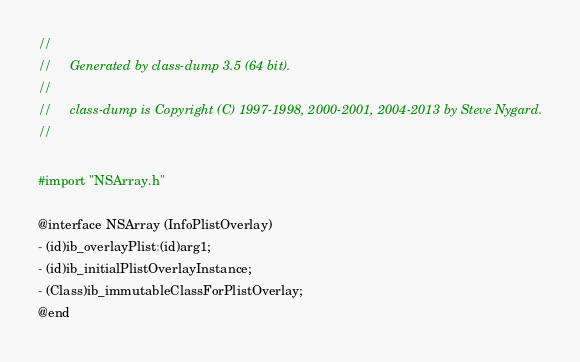<code> <loc_0><loc_0><loc_500><loc_500><_C_>//
//     Generated by class-dump 3.5 (64 bit).
//
//     class-dump is Copyright (C) 1997-1998, 2000-2001, 2004-2013 by Steve Nygard.
//

#import "NSArray.h"

@interface NSArray (InfoPlistOverlay)
- (id)ib_overlayPlist:(id)arg1;
- (id)ib_initialPlistOverlayInstance;
- (Class)ib_immutableClassForPlistOverlay;
@end

</code> 